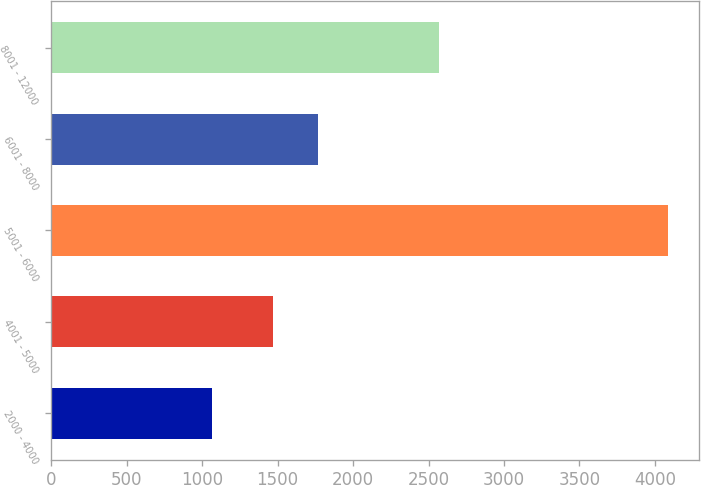<chart> <loc_0><loc_0><loc_500><loc_500><bar_chart><fcel>2000 - 4000<fcel>4001 - 5000<fcel>5001 - 6000<fcel>6001 - 8000<fcel>8001 - 12000<nl><fcel>1065<fcel>1467<fcel>4089<fcel>1769.4<fcel>2572<nl></chart> 